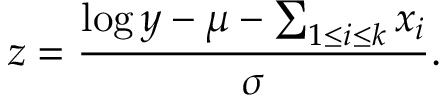Convert formula to latex. <formula><loc_0><loc_0><loc_500><loc_500>z = \frac { \log y - \mu - \sum _ { 1 \leq i \leq k } x _ { i } } { \sigma } .</formula> 